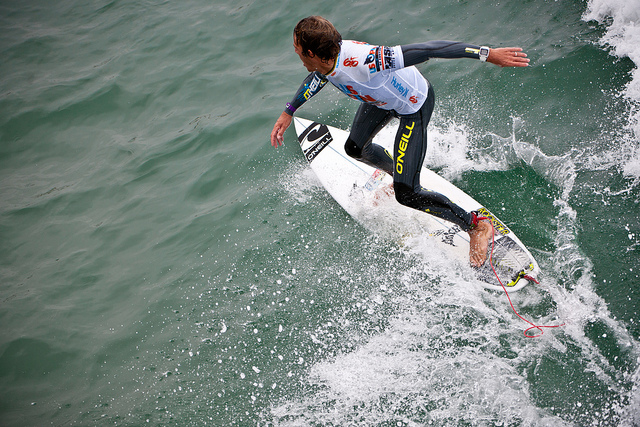Read and extract the text from this image. ONEILL 